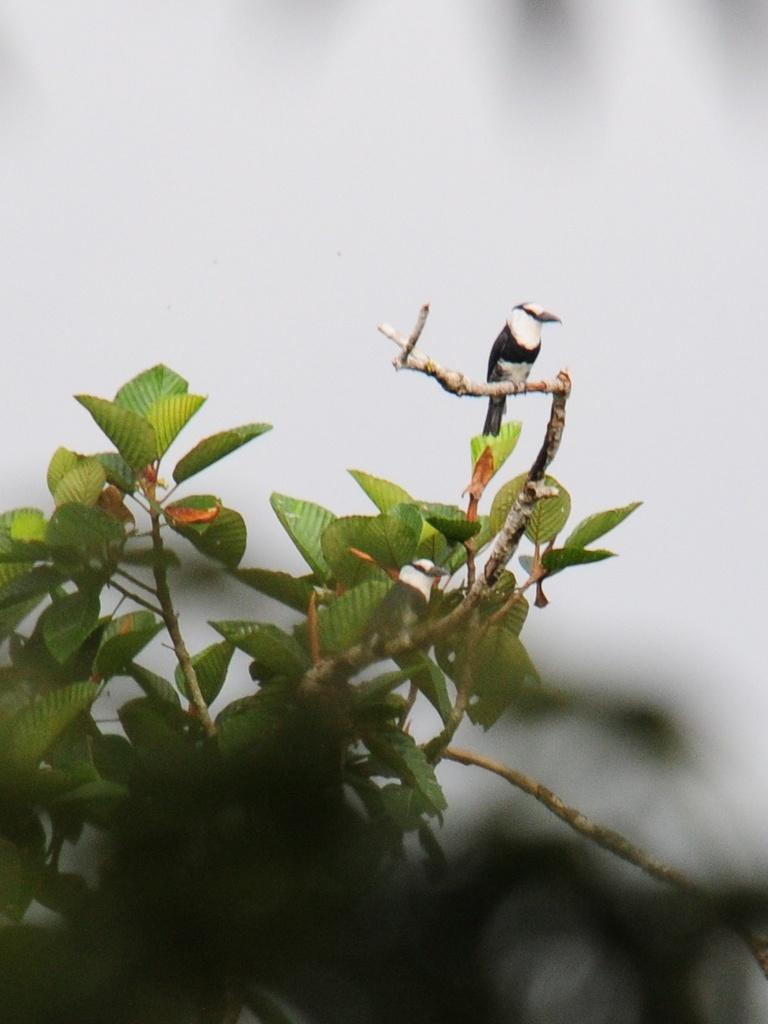What type of animal is in the image? There is a bird in the image. Where is the bird located? The bird is standing on the stem of a plant. Can you describe the background of the image? The background of the image is blurry. What type of wheel can be seen in the image? There is no wheel present in the image; it features a bird standing on a plant. Is there a fireman in the image? There is no fireman present in the image; it features a bird standing on a plant. 